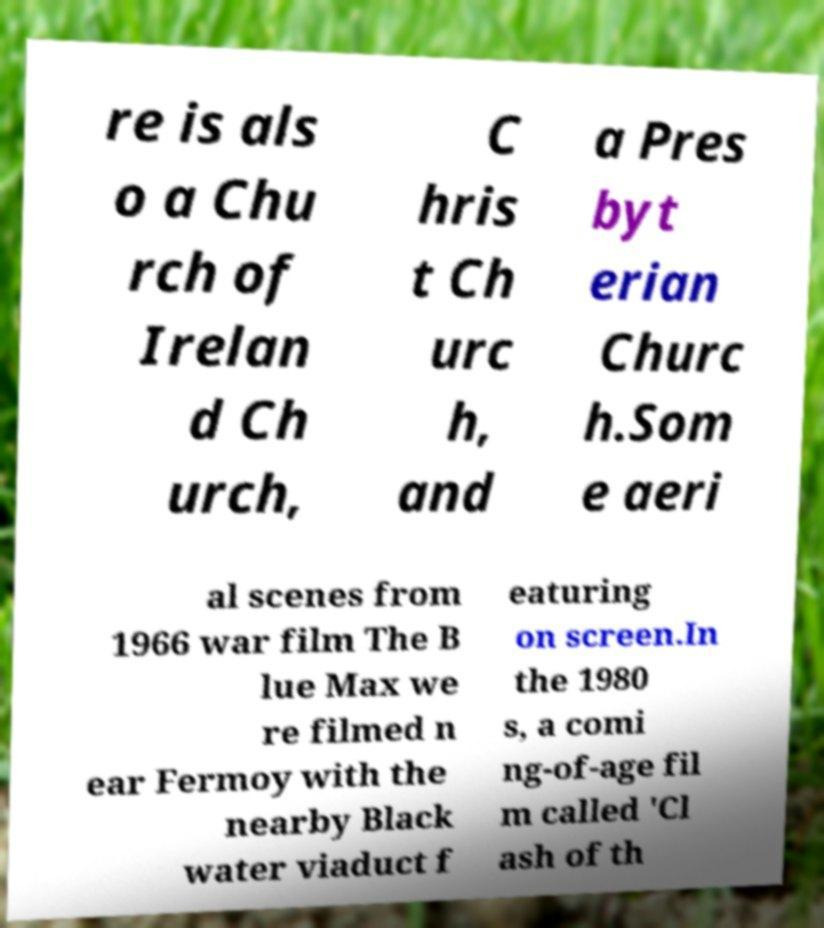Can you read and provide the text displayed in the image?This photo seems to have some interesting text. Can you extract and type it out for me? re is als o a Chu rch of Irelan d Ch urch, C hris t Ch urc h, and a Pres byt erian Churc h.Som e aeri al scenes from 1966 war film The B lue Max we re filmed n ear Fermoy with the nearby Black water viaduct f eaturing on screen.In the 1980 s, a comi ng-of-age fil m called 'Cl ash of th 